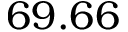<formula> <loc_0><loc_0><loc_500><loc_500>6 9 . 6 6</formula> 